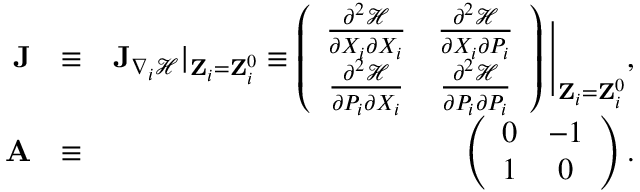<formula> <loc_0><loc_0><loc_500><loc_500>\begin{array} { r l r } { J } & { \equiv } & { { J } _ { \nabla _ { i } \mathcal { H } } | _ { { Z } _ { i } = { Z } _ { i } ^ { 0 } } \equiv \left ( \begin{array} { c c } { \frac { \partial ^ { 2 } \mathcal { H } } { \partial X _ { i } \partial X _ { i } } } & { \frac { \partial ^ { 2 } \mathcal { H } } { \partial X _ { i } \partial P _ { i } } } \\ { \frac { \partial ^ { 2 } \mathcal { H } } { \partial P _ { i } \partial X _ { i } } } & { \frac { \partial ^ { 2 } \mathcal { H } } { \partial P _ { i } \partial P _ { i } } } \end{array} \right ) \Big | _ { { Z } _ { i } = { Z } _ { i } ^ { 0 } } , } \\ { A } & { \equiv } & { \left ( \begin{array} { c c } { 0 } & { - 1 } \\ { 1 } & { 0 } \end{array} \right ) . } \end{array}</formula> 